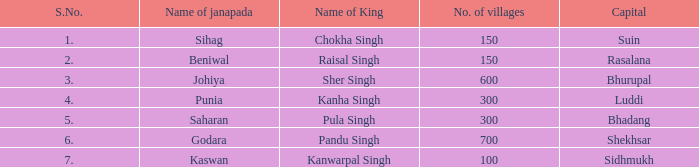What is the highest S number with a capital of Shekhsar? 6.0. 